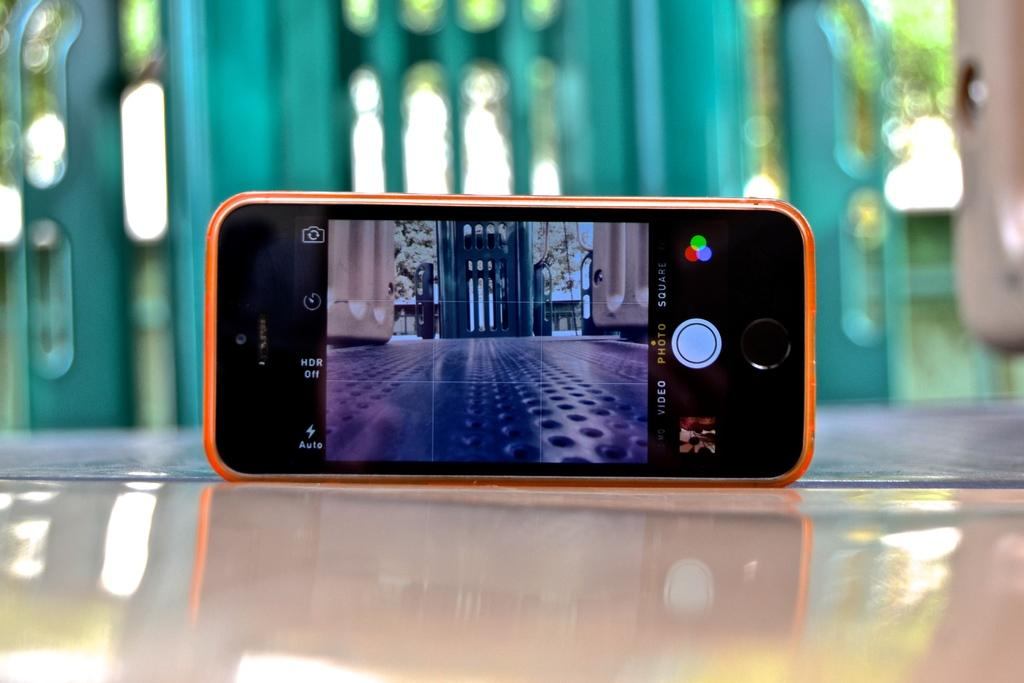<image>
Relay a brief, clear account of the picture shown. HDR off reads the setting of this camera phone. 